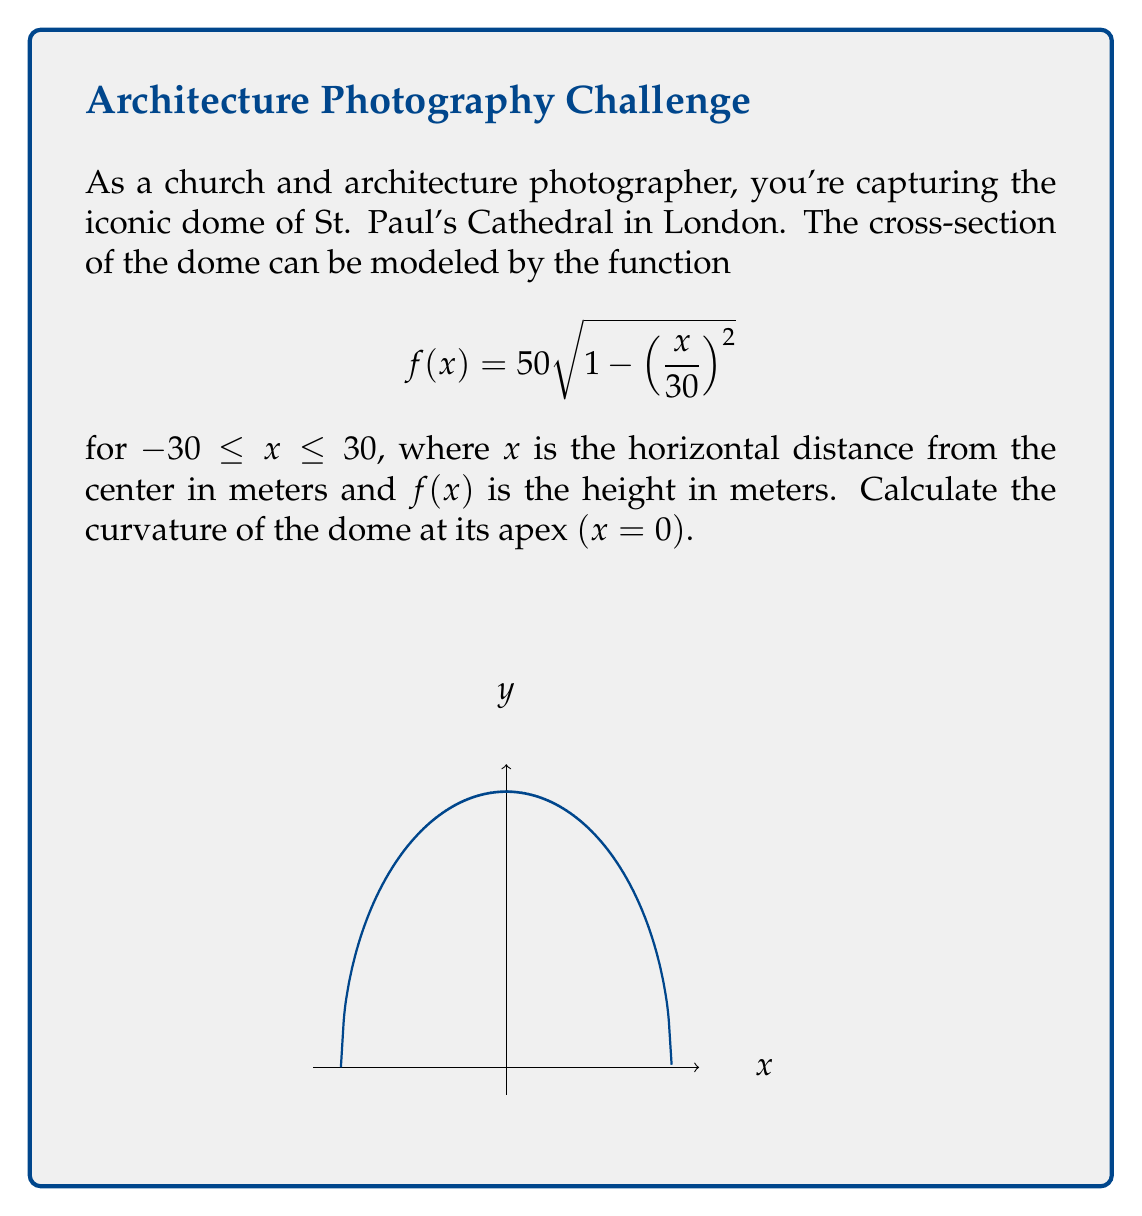What is the answer to this math problem? To find the curvature at the apex of the dome, we'll follow these steps:

1) The formula for curvature is:

   $$\kappa = \frac{|f''(x)|}{(1 + (f'(x))^2)^{3/2}}$$

2) First, let's find $f'(x)$:
   $$f'(x) = 50 \cdot \frac{1}{2\sqrt{1 - (\frac{x}{30})^2}} \cdot (-2)(\frac{x}{30})(\frac{1}{30}) = -\frac{50x}{900\sqrt{1 - (\frac{x}{30})^2}}$$

3) Now, let's find $f''(x)$:
   $$f''(x) = -\frac{50}{900}\left(\frac{\sqrt{1 - (\frac{x}{30})^2} + \frac{x^2}{900\sqrt{1 - (\frac{x}{30})^2}}}{1 - (\frac{x}{30})^2}\right)$$

4) At the apex, $x = 0$. Let's evaluate $f'(0)$ and $f''(0)$:
   
   $f'(0) = 0$
   
   $f''(0) = -\frac{50}{900} = -\frac{1}{18}$

5) Now we can substitute these values into the curvature formula:

   $$\kappa = \frac{|\frac{1}{18}|}{(1 + 0^2)^{3/2}} = \frac{1}{18}$$

Thus, the curvature at the apex of the dome is $\frac{1}{18}$ m⁻¹.
Answer: $\frac{1}{18}$ m⁻¹ 